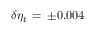<formula> <loc_0><loc_0><loc_500><loc_500>\delta \eta _ { t } \, = \, \pm 0 . 0 0 4</formula> 